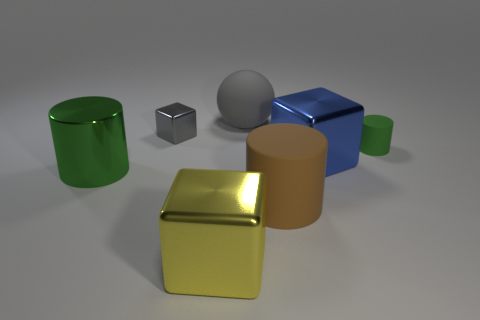Add 3 gray metal things. How many objects exist? 10 Subtract all spheres. How many objects are left? 6 Subtract all large gray matte objects. Subtract all blue cubes. How many objects are left? 5 Add 6 tiny green objects. How many tiny green objects are left? 7 Add 4 small gray metallic cubes. How many small gray metallic cubes exist? 5 Subtract 1 yellow blocks. How many objects are left? 6 